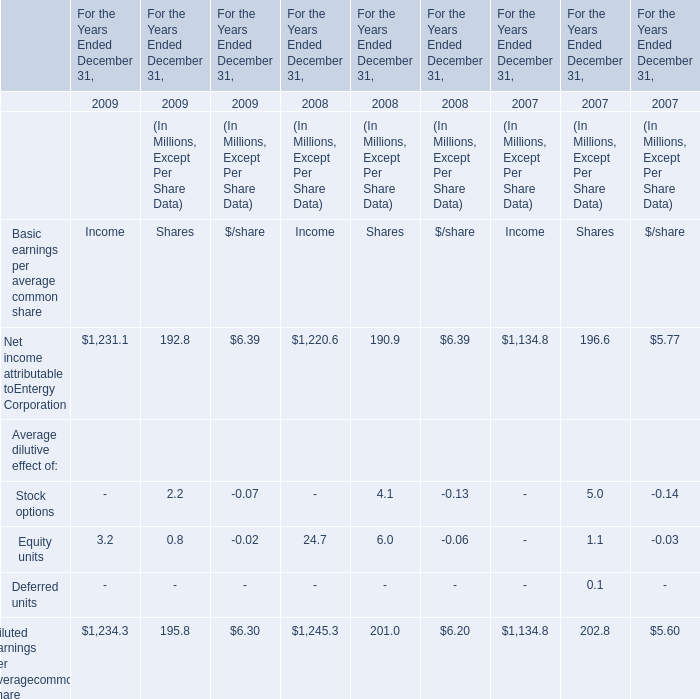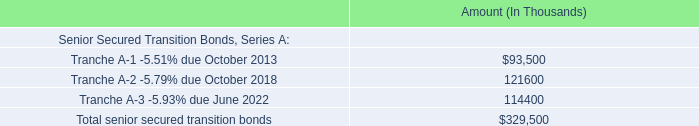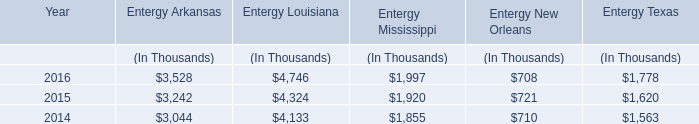What's the average of Net income attributable to Entergy Corporation in 2009? (in million) 
Computations: (((1231.1 + 192.8) + 6.39) / 3)
Answer: 476.76333. 